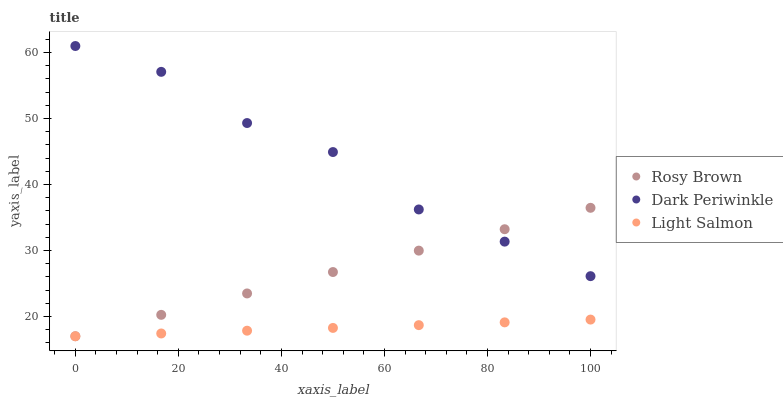Does Light Salmon have the minimum area under the curve?
Answer yes or no. Yes. Does Dark Periwinkle have the maximum area under the curve?
Answer yes or no. Yes. Does Rosy Brown have the minimum area under the curve?
Answer yes or no. No. Does Rosy Brown have the maximum area under the curve?
Answer yes or no. No. Is Light Salmon the smoothest?
Answer yes or no. Yes. Is Dark Periwinkle the roughest?
Answer yes or no. Yes. Is Rosy Brown the smoothest?
Answer yes or no. No. Is Rosy Brown the roughest?
Answer yes or no. No. Does Light Salmon have the lowest value?
Answer yes or no. Yes. Does Dark Periwinkle have the lowest value?
Answer yes or no. No. Does Dark Periwinkle have the highest value?
Answer yes or no. Yes. Does Rosy Brown have the highest value?
Answer yes or no. No. Is Light Salmon less than Dark Periwinkle?
Answer yes or no. Yes. Is Dark Periwinkle greater than Light Salmon?
Answer yes or no. Yes. Does Light Salmon intersect Rosy Brown?
Answer yes or no. Yes. Is Light Salmon less than Rosy Brown?
Answer yes or no. No. Is Light Salmon greater than Rosy Brown?
Answer yes or no. No. Does Light Salmon intersect Dark Periwinkle?
Answer yes or no. No. 